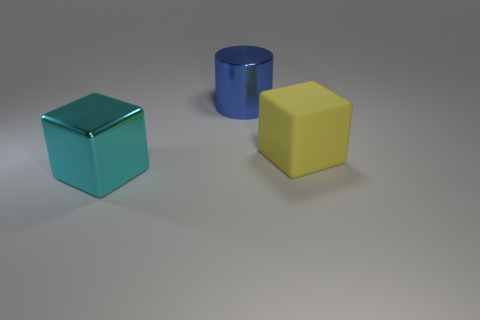What number of other things are there of the same size as the rubber cube? Apart from the rubber cube, there are two other objects in the image that appear to share a similar size—another cube and a cylinder. 